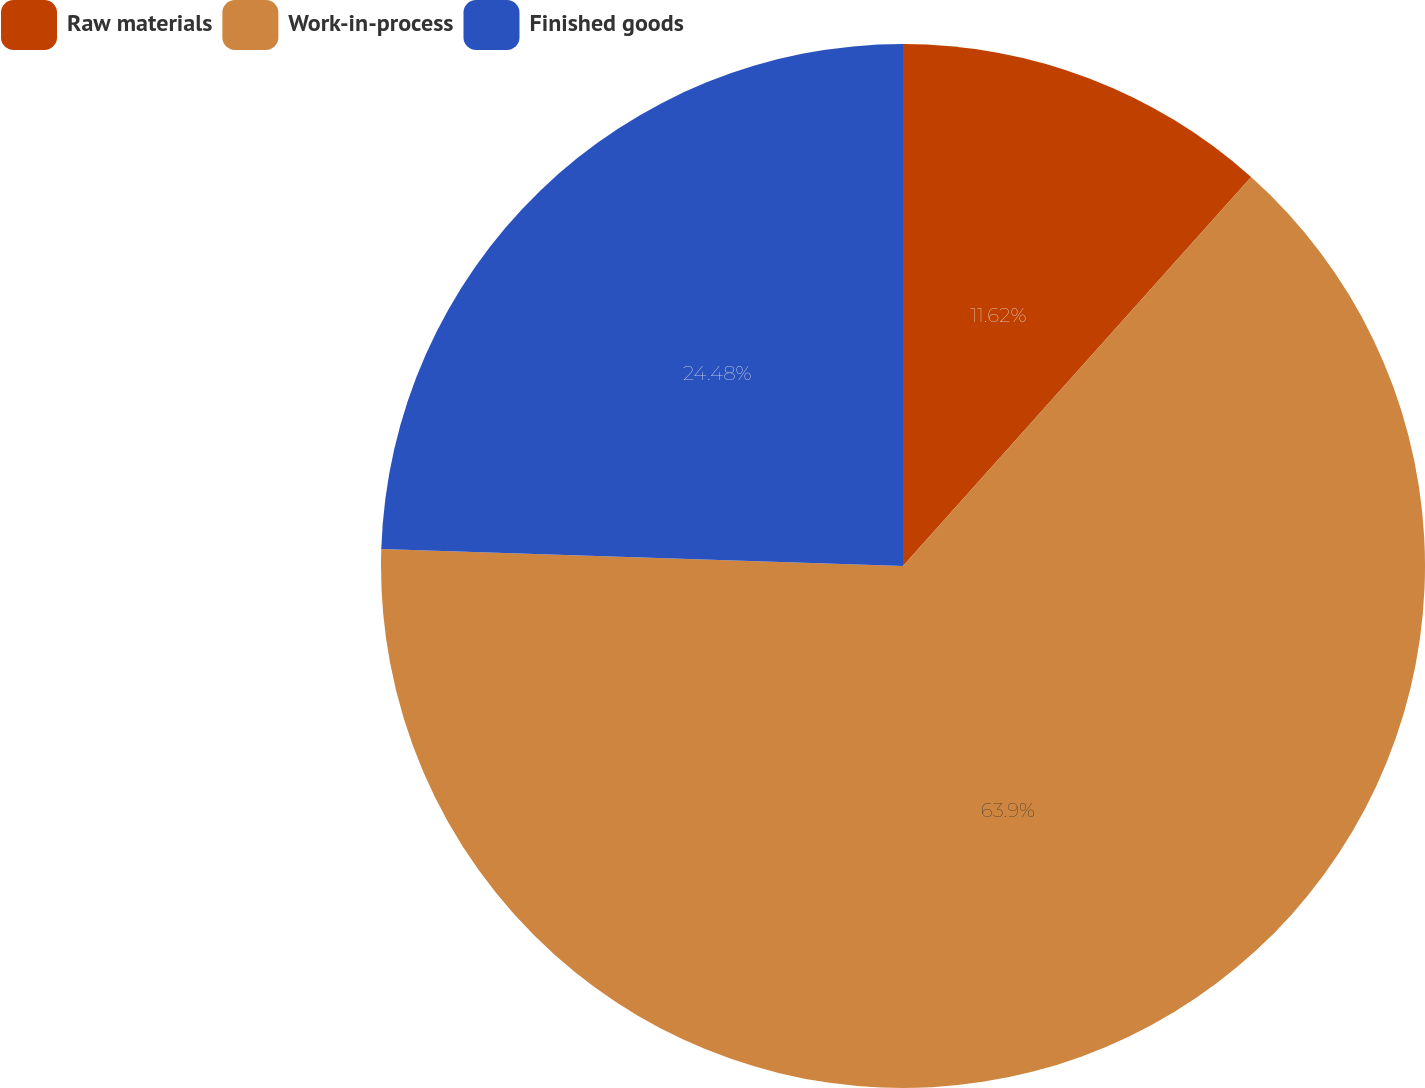<chart> <loc_0><loc_0><loc_500><loc_500><pie_chart><fcel>Raw materials<fcel>Work-in-process<fcel>Finished goods<nl><fcel>11.62%<fcel>63.9%<fcel>24.48%<nl></chart> 